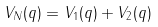<formula> <loc_0><loc_0><loc_500><loc_500>V _ { N } ( q ) = V _ { 1 } ( q ) + V _ { 2 } ( q )</formula> 